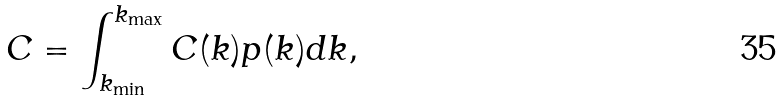<formula> <loc_0><loc_0><loc_500><loc_500>C = \int _ { k _ { \min } } ^ { k _ { \max } } C ( k ) p ( k ) d k ,</formula> 